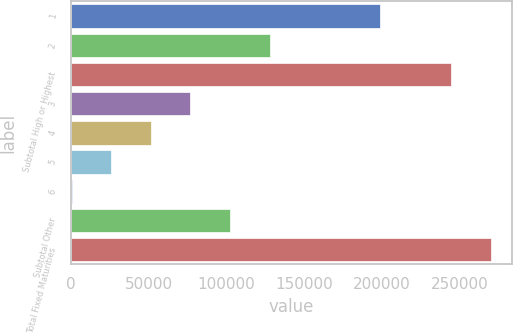Convert chart. <chart><loc_0><loc_0><loc_500><loc_500><bar_chart><fcel>1<fcel>2<fcel>Subtotal High or Highest<fcel>3<fcel>4<fcel>5<fcel>6<fcel>Subtotal Other<fcel>Total Fixed Maturities<nl><fcel>198688<fcel>127701<fcel>244572<fcel>76773.8<fcel>51310.2<fcel>25846.6<fcel>383<fcel>102237<fcel>270036<nl></chart> 